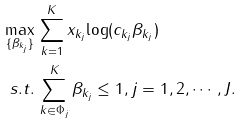Convert formula to latex. <formula><loc_0><loc_0><loc_500><loc_500>\max _ { \{ \beta _ { k _ { j } } \} } & \, \sum _ { k = 1 } ^ { K } x _ { k _ { j } } { \log ( c _ { k _ { j } } \beta _ { k _ { j } } ) } \\ s . t . & \, \sum _ { k \in \Phi _ { j } } ^ { K } \beta _ { k _ { j } } \leq 1 , j = 1 , 2 , \cdots , J .</formula> 